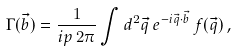Convert formula to latex. <formula><loc_0><loc_0><loc_500><loc_500>\Gamma ( \vec { b } ) = \frac { 1 } { i p \, 2 \pi } \int d ^ { 2 } \vec { q } \, e ^ { - i \vec { q } \cdot \vec { b } } \, f ( \vec { q } ) \, ,</formula> 